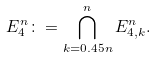Convert formula to latex. <formula><loc_0><loc_0><loc_500><loc_500>E ^ { n } _ { 4 } \colon = \bigcap _ { k = 0 . 4 5 n } ^ { n } E ^ { n } _ { 4 , k } .</formula> 